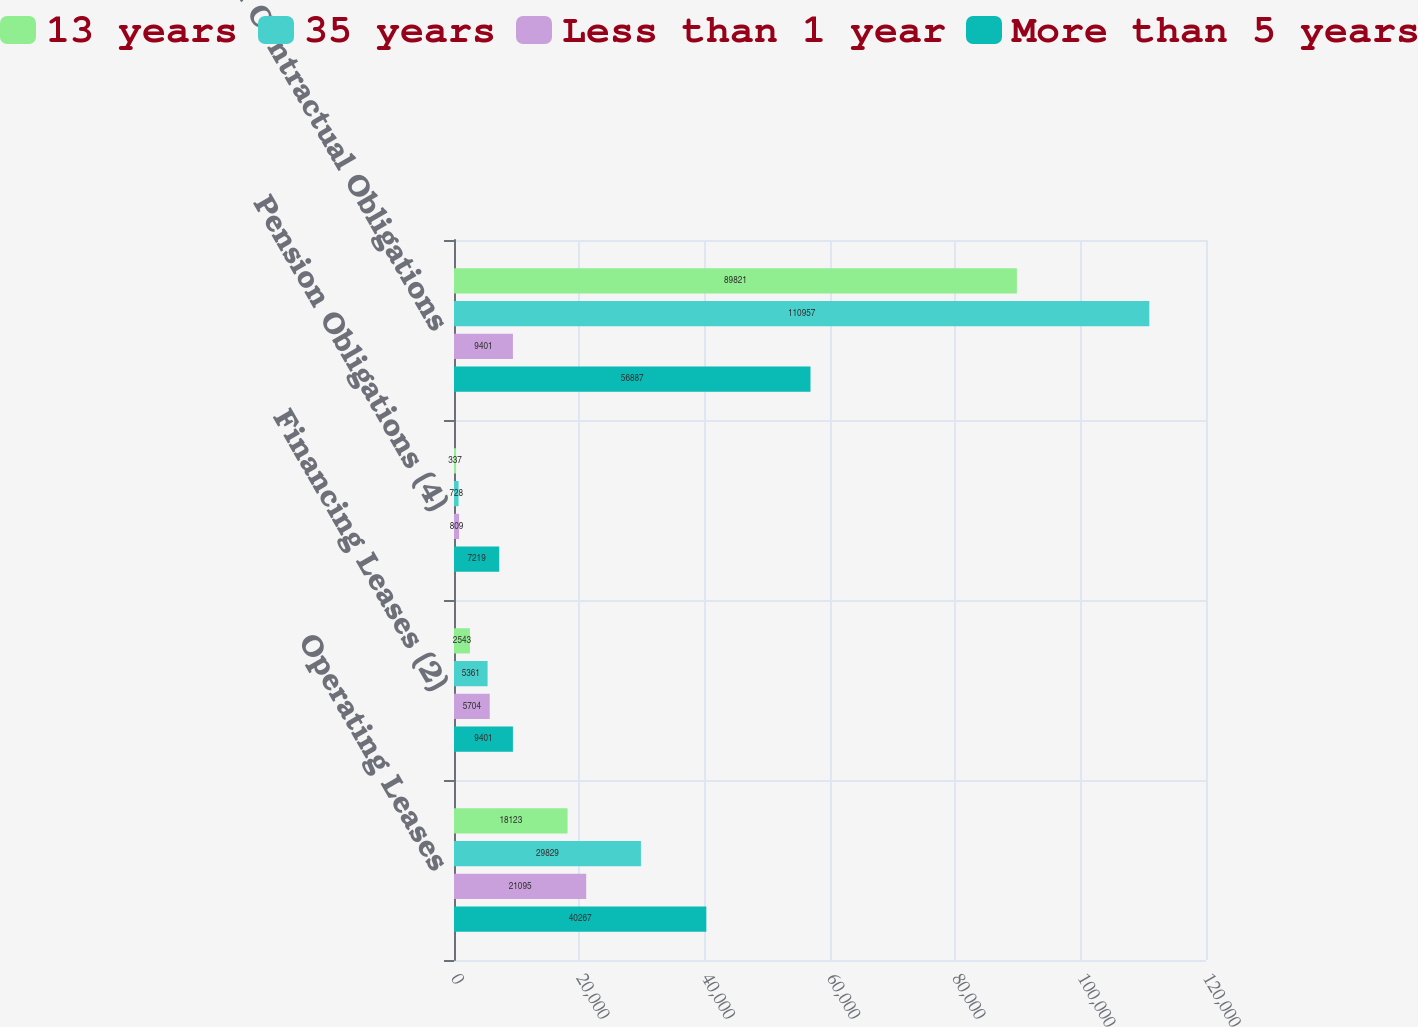Convert chart to OTSL. <chart><loc_0><loc_0><loc_500><loc_500><stacked_bar_chart><ecel><fcel>Operating Leases<fcel>Financing Leases (2)<fcel>Pension Obligations (4)<fcel>Total Contractual Obligations<nl><fcel>13 years<fcel>18123<fcel>2543<fcel>337<fcel>89821<nl><fcel>35 years<fcel>29829<fcel>5361<fcel>728<fcel>110957<nl><fcel>Less than 1 year<fcel>21095<fcel>5704<fcel>809<fcel>9401<nl><fcel>More than 5 years<fcel>40267<fcel>9401<fcel>7219<fcel>56887<nl></chart> 